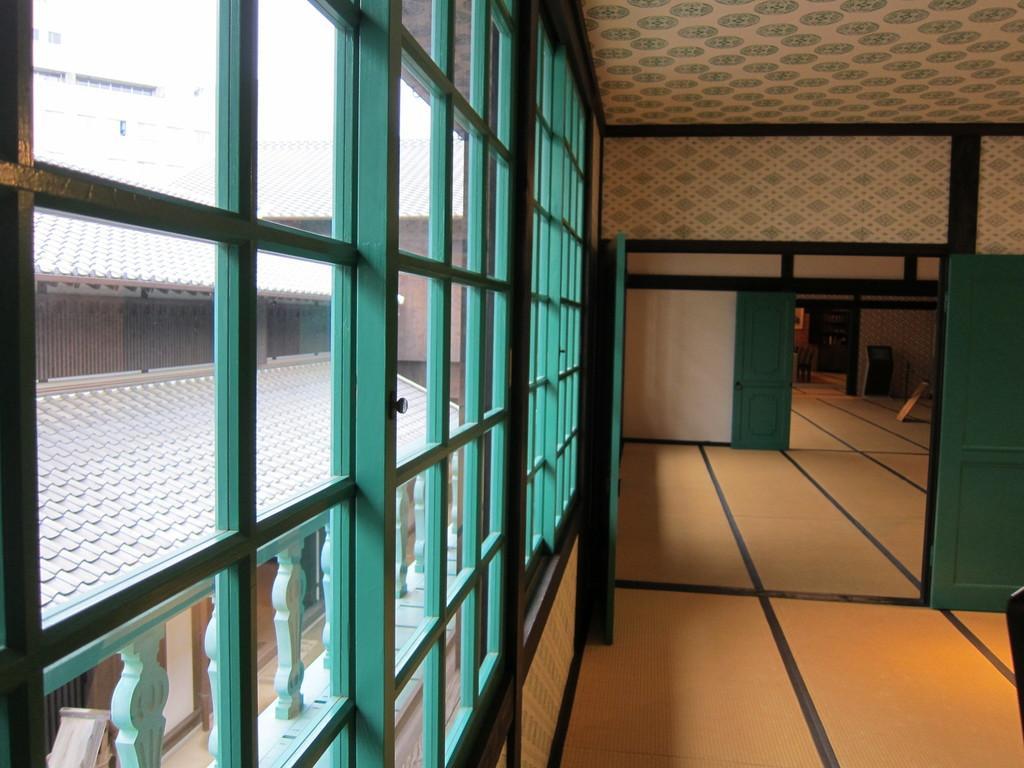Could you give a brief overview of what you see in this image? This picture describes about inside view of a building, on the left side of the image we can see few glasses, from the glasses we can find few more buildings. 